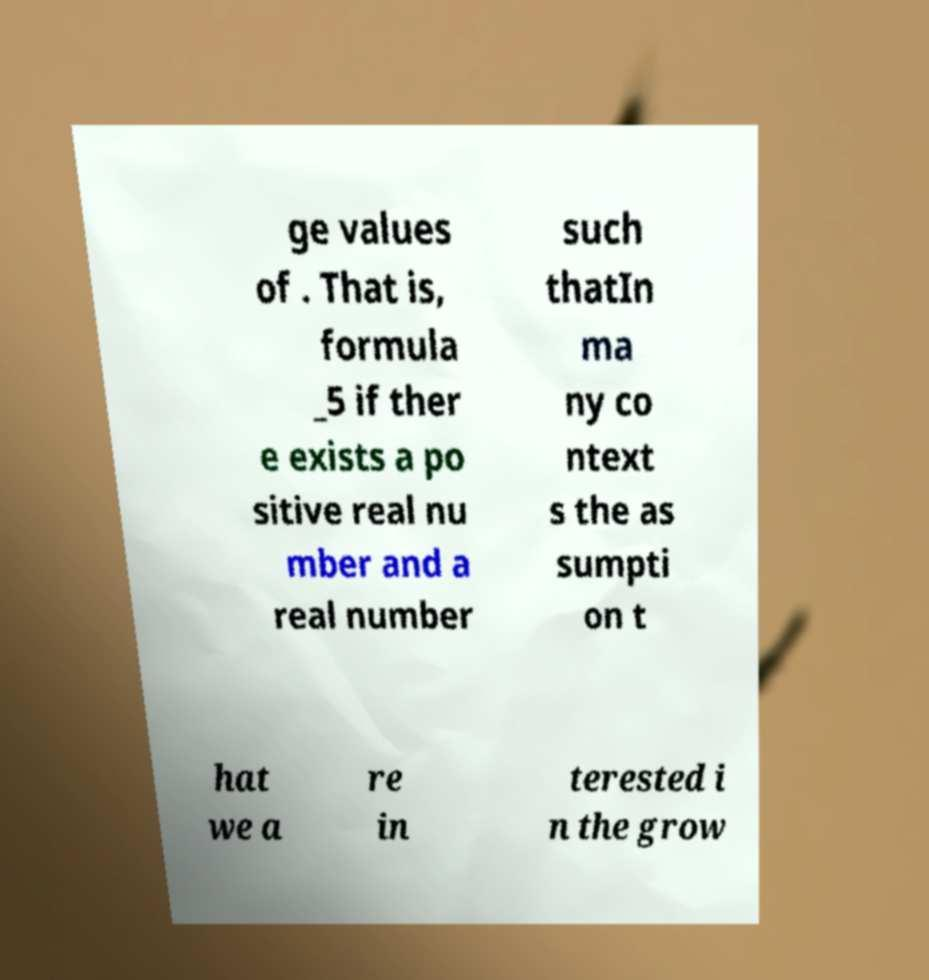Can you accurately transcribe the text from the provided image for me? ge values of . That is, formula _5 if ther e exists a po sitive real nu mber and a real number such thatIn ma ny co ntext s the as sumpti on t hat we a re in terested i n the grow 